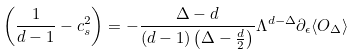Convert formula to latex. <formula><loc_0><loc_0><loc_500><loc_500>\left ( \frac { 1 } { d - 1 } - c _ { s } ^ { 2 } \right ) = - \frac { \Delta - d } { ( d - 1 ) \left ( \Delta - \frac { d } { 2 } \right ) } \Lambda ^ { d - \Delta } \partial _ { \epsilon } \langle O _ { \Delta } \rangle</formula> 